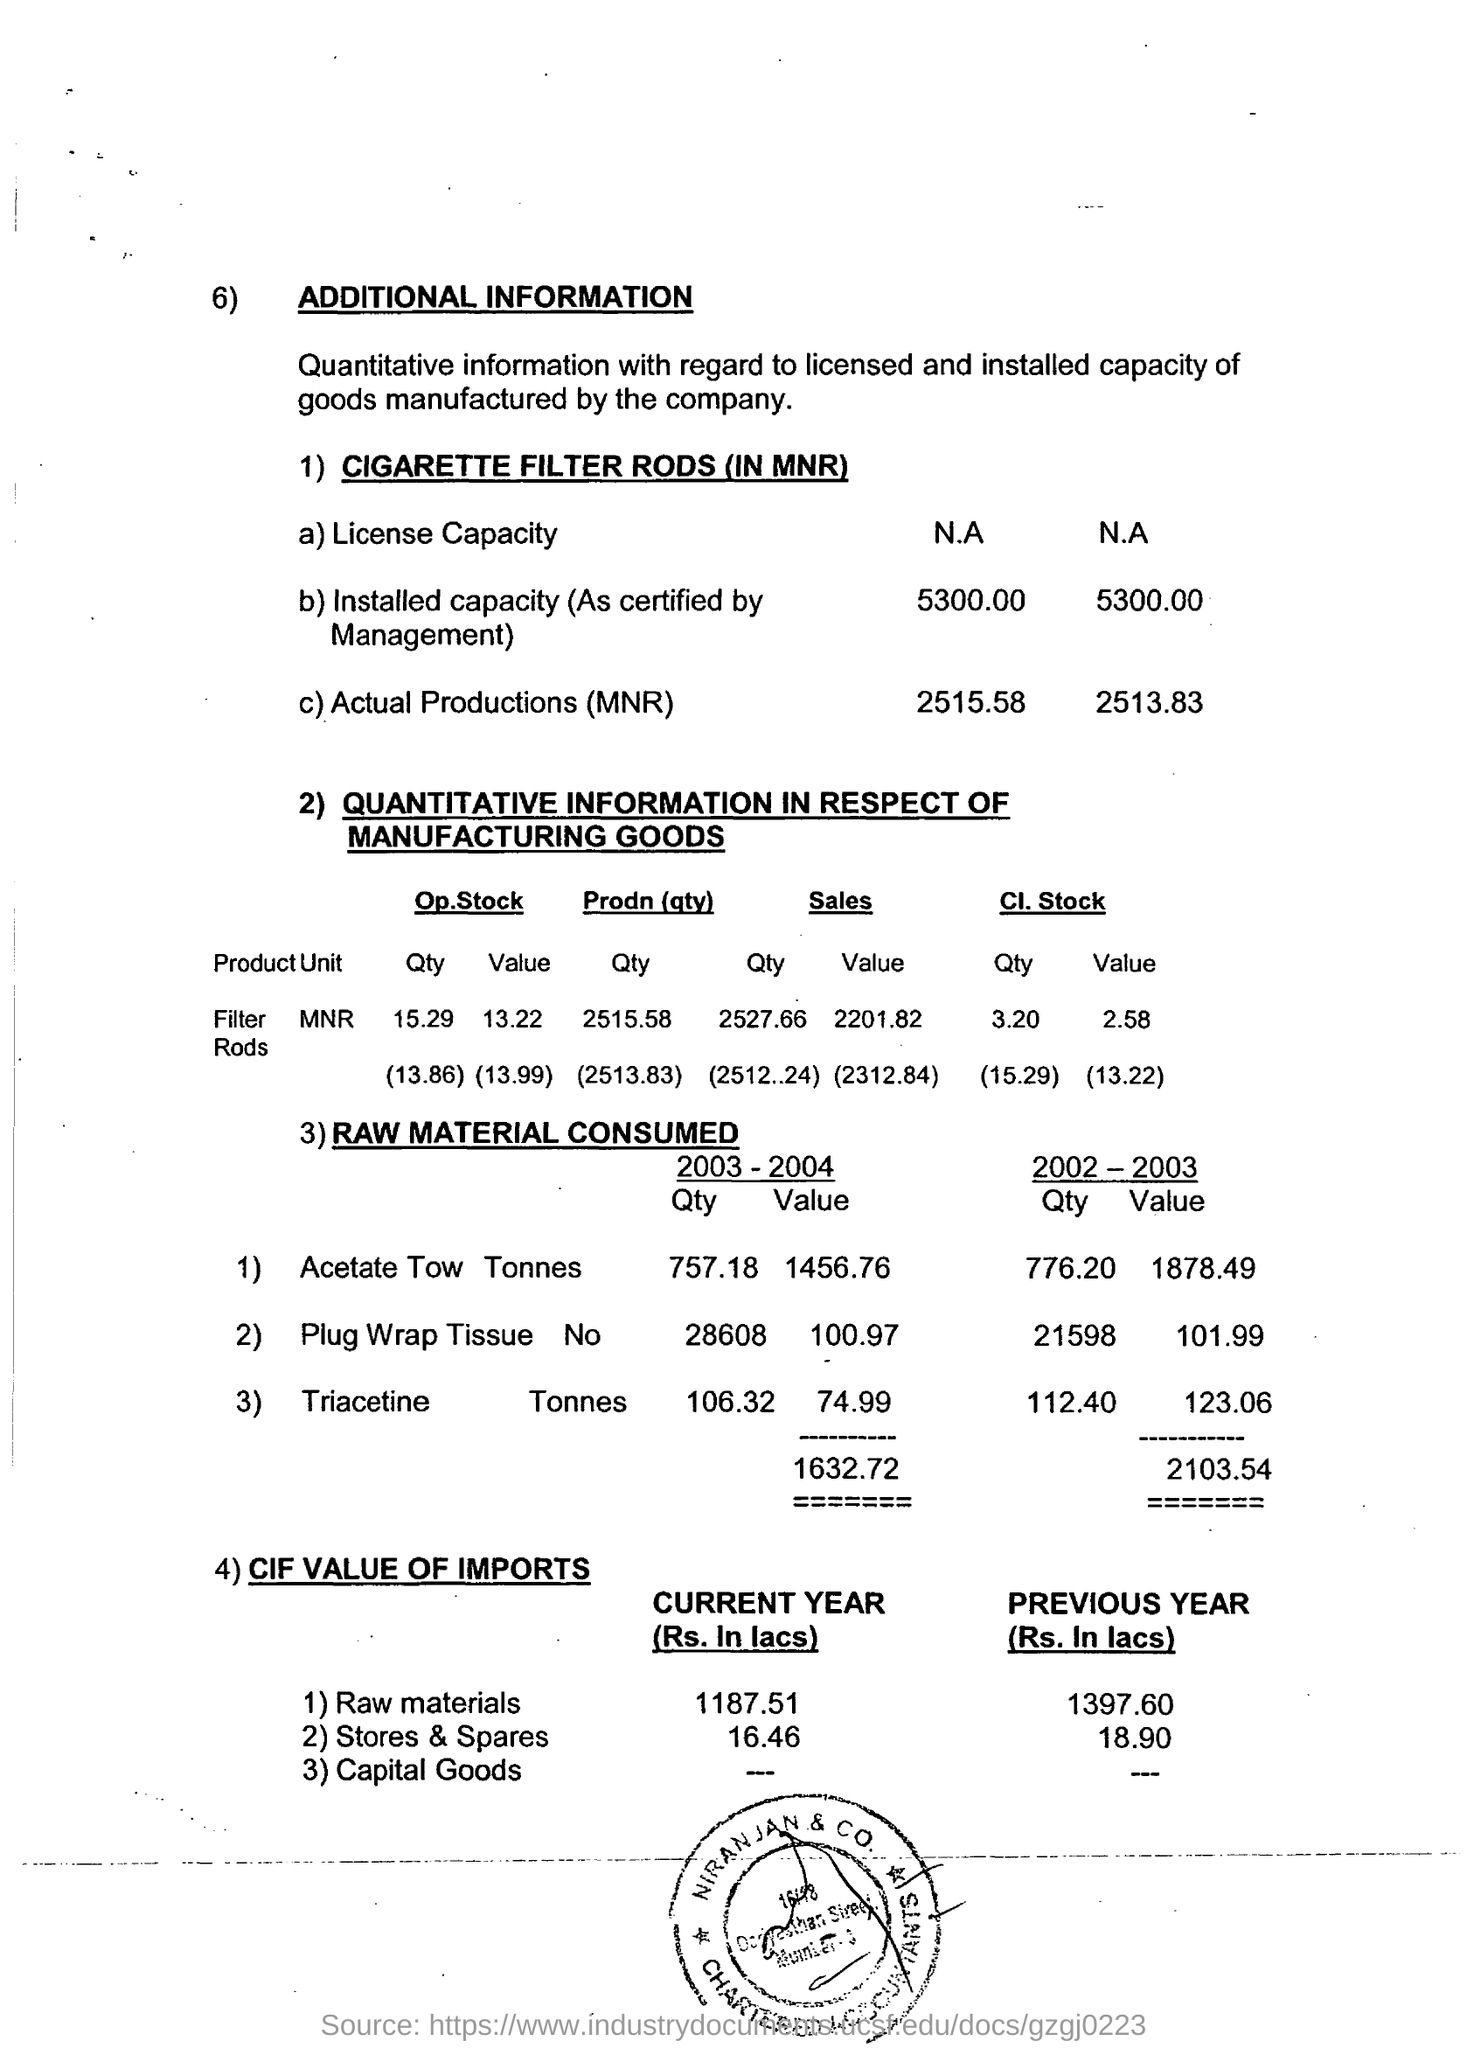What is the value of triacetine consumed in 2004?
Give a very brief answer. 74.99. What is the total value of raw materials consumed in 2004?
Keep it short and to the point. 1632.72. What is the cif value of imports for raw materials in current year?
Keep it short and to the point. 1187.51. 